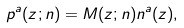Convert formula to latex. <formula><loc_0><loc_0><loc_500><loc_500>p ^ { a } ( z ; n ) = M ( z ; n ) n ^ { a } ( z ) ,</formula> 